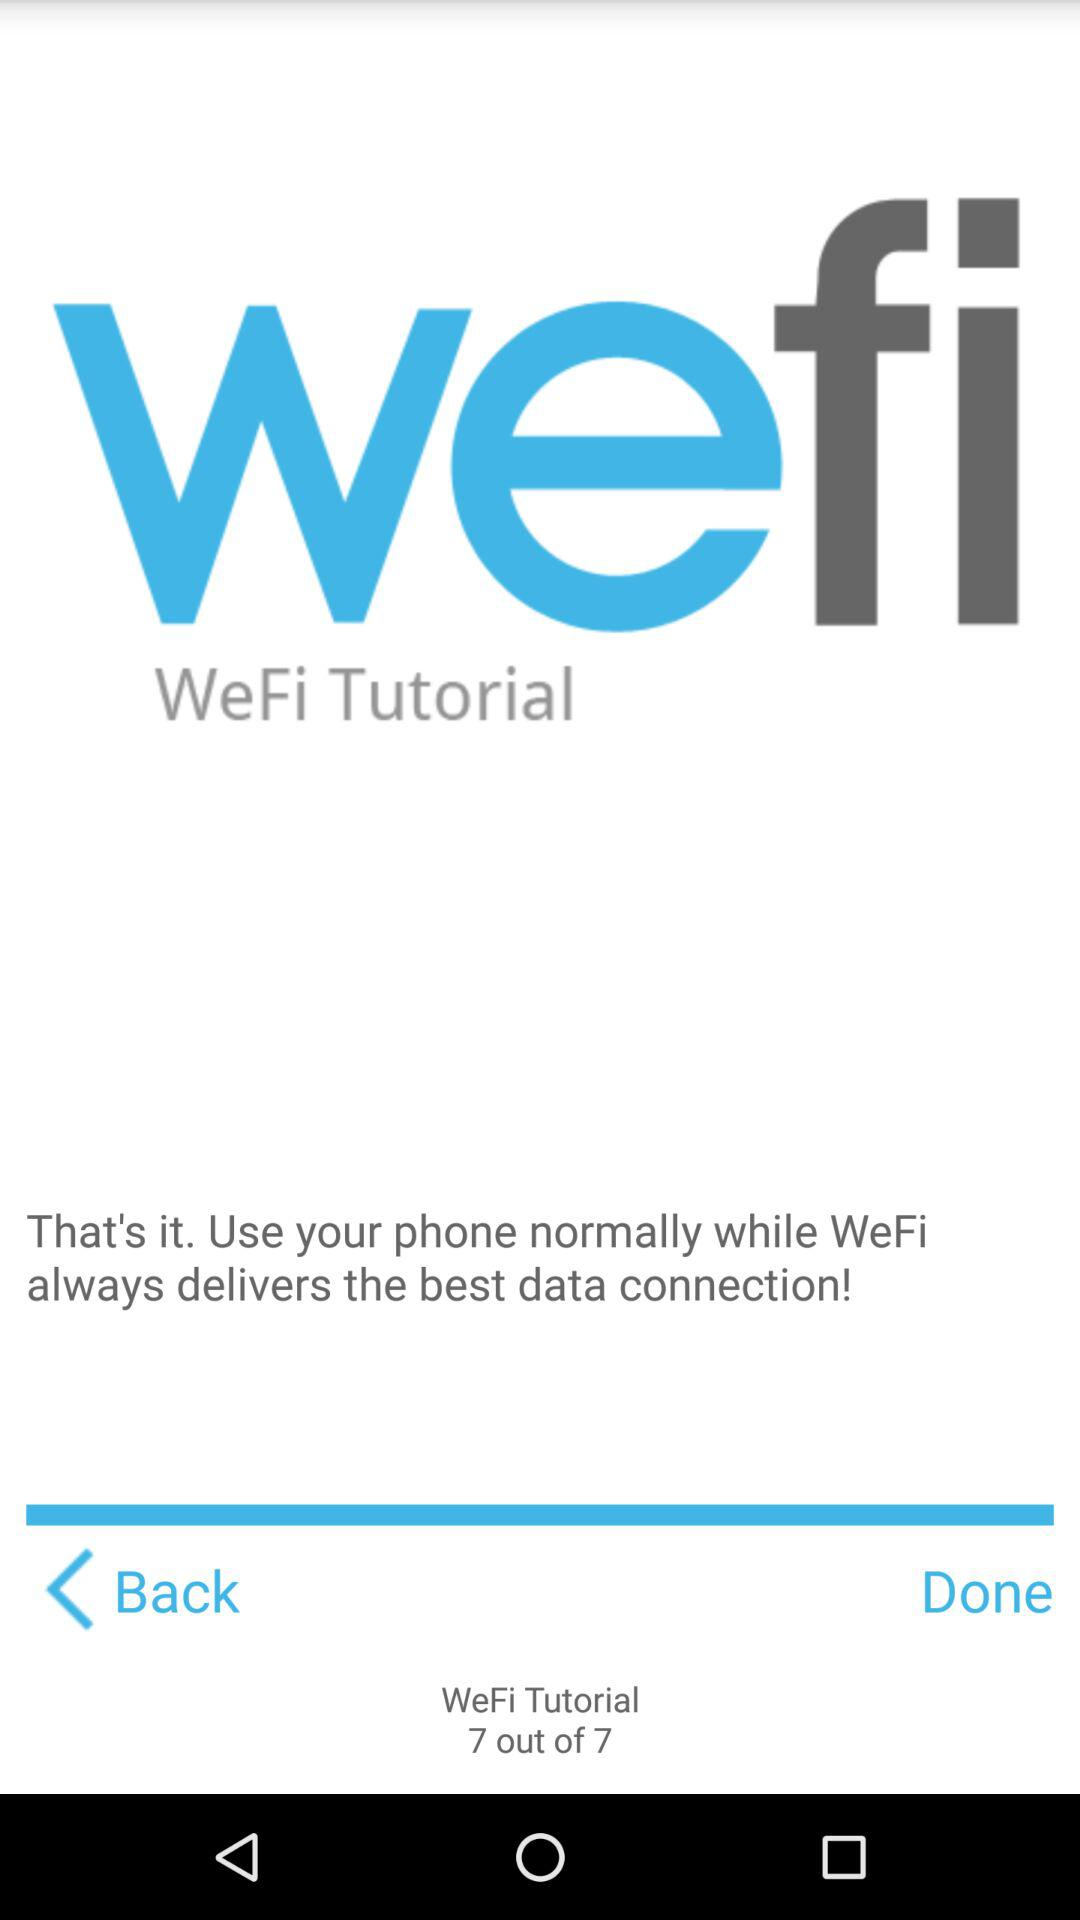Which step of the tutorial is the person in? The person is in the seventh step. 